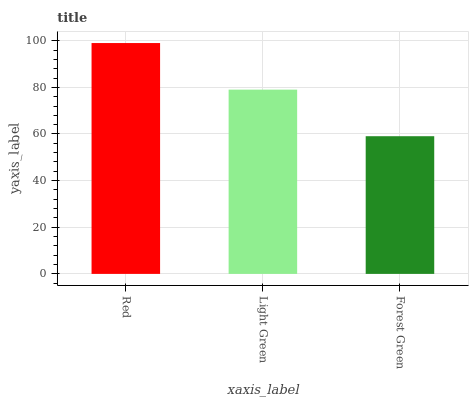Is Forest Green the minimum?
Answer yes or no. Yes. Is Red the maximum?
Answer yes or no. Yes. Is Light Green the minimum?
Answer yes or no. No. Is Light Green the maximum?
Answer yes or no. No. Is Red greater than Light Green?
Answer yes or no. Yes. Is Light Green less than Red?
Answer yes or no. Yes. Is Light Green greater than Red?
Answer yes or no. No. Is Red less than Light Green?
Answer yes or no. No. Is Light Green the high median?
Answer yes or no. Yes. Is Light Green the low median?
Answer yes or no. Yes. Is Forest Green the high median?
Answer yes or no. No. Is Red the low median?
Answer yes or no. No. 